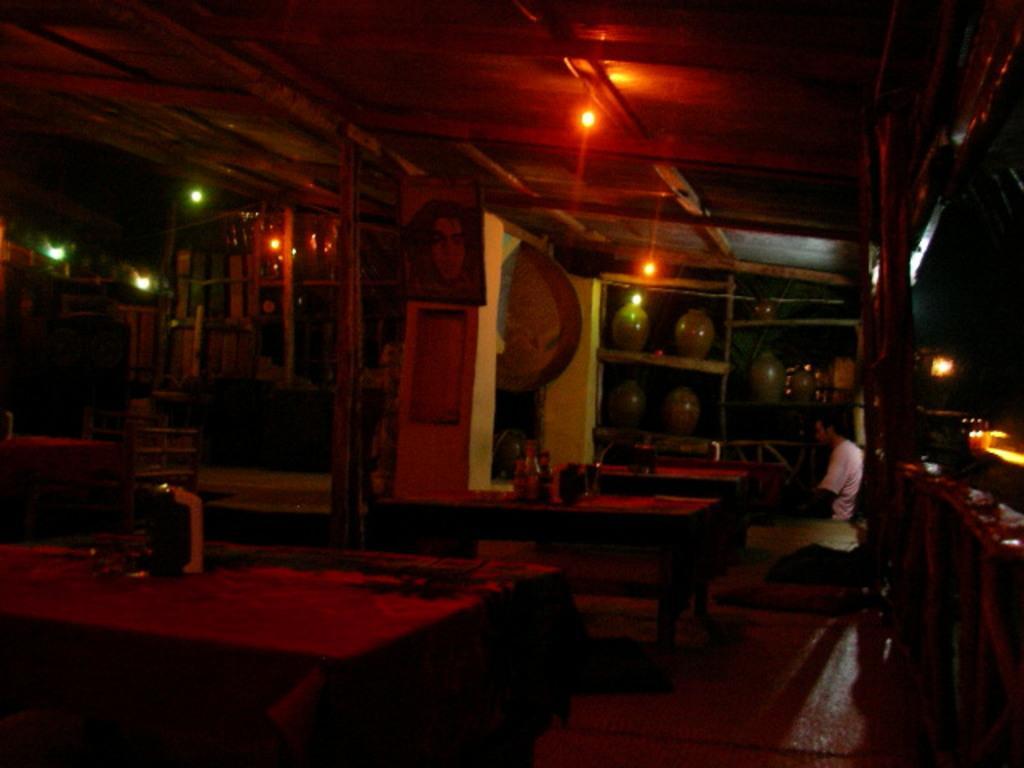Can you describe this image briefly? Here there are lights, a person is sitting, this is table. 